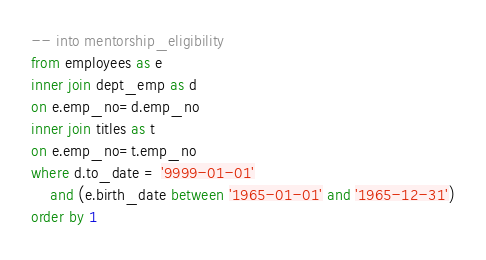<code> <loc_0><loc_0><loc_500><loc_500><_SQL_>-- into mentorship_eligibility
from employees as e
inner join dept_emp as d
on e.emp_no=d.emp_no
inner join titles as t
on e.emp_no=t.emp_no
where d.to_date = '9999-01-01'
	and (e.birth_date between '1965-01-01' and '1965-12-31')
order by 1



</code> 